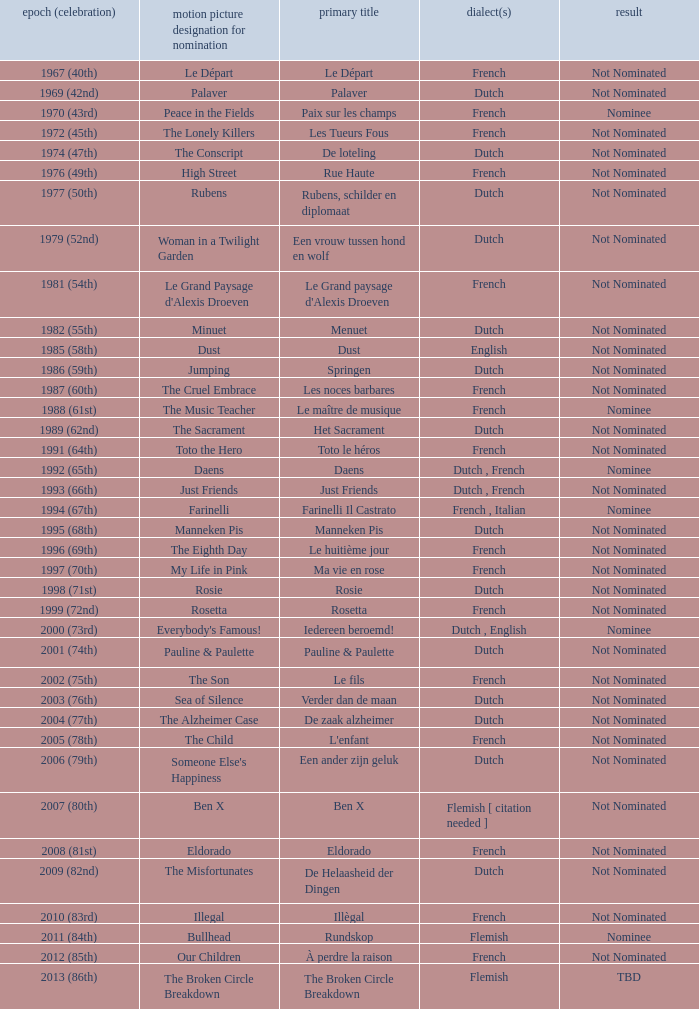What was the title used for Rosie, the film nominated for the dutch language? Rosie. 